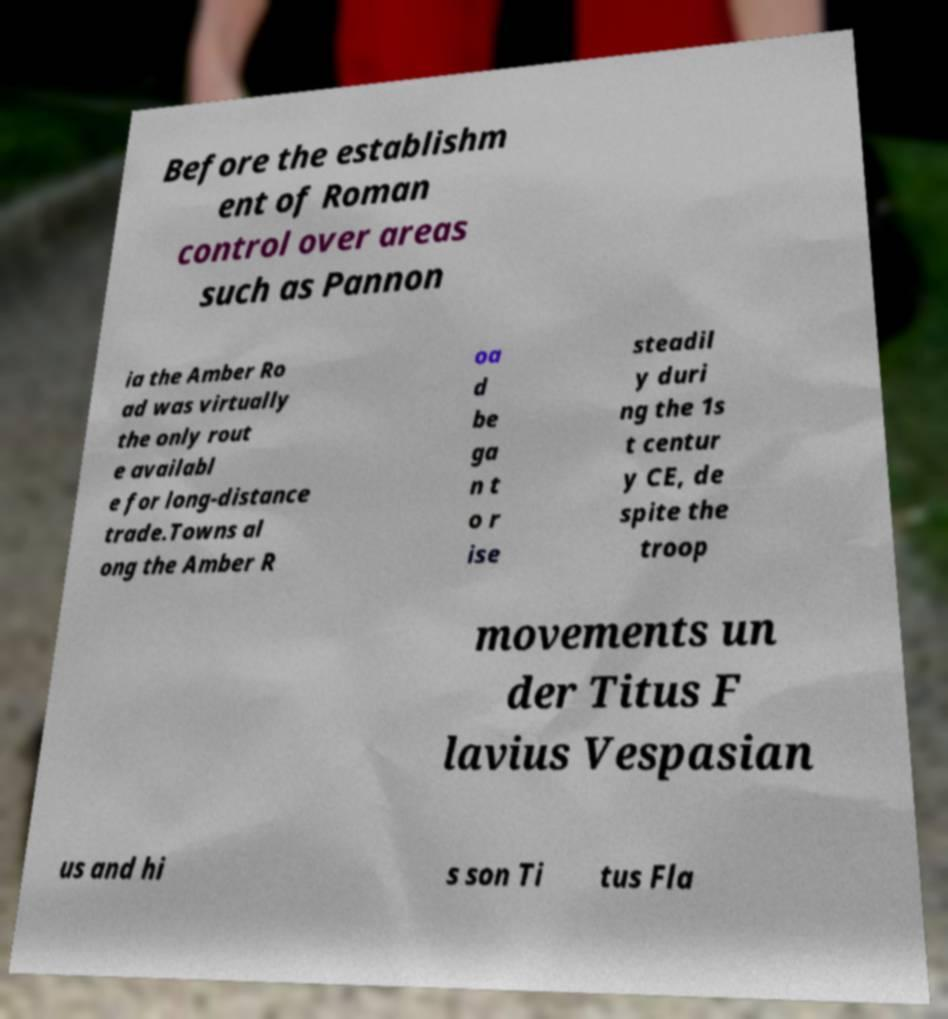For documentation purposes, I need the text within this image transcribed. Could you provide that? Before the establishm ent of Roman control over areas such as Pannon ia the Amber Ro ad was virtually the only rout e availabl e for long-distance trade.Towns al ong the Amber R oa d be ga n t o r ise steadil y duri ng the 1s t centur y CE, de spite the troop movements un der Titus F lavius Vespasian us and hi s son Ti tus Fla 